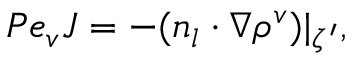<formula> <loc_0><loc_0><loc_500><loc_500>P e _ { v } J = - ( n _ { l } \cdot \nabla \rho ^ { v } ) | _ { \zeta ^ { \prime } } ,</formula> 